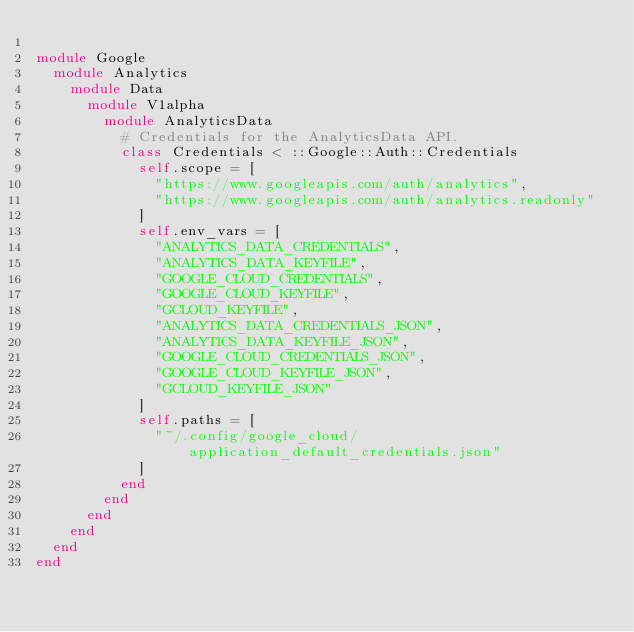Convert code to text. <code><loc_0><loc_0><loc_500><loc_500><_Ruby_>
module Google
  module Analytics
    module Data
      module V1alpha
        module AnalyticsData
          # Credentials for the AnalyticsData API.
          class Credentials < ::Google::Auth::Credentials
            self.scope = [
              "https://www.googleapis.com/auth/analytics",
              "https://www.googleapis.com/auth/analytics.readonly"
            ]
            self.env_vars = [
              "ANALYTICS_DATA_CREDENTIALS",
              "ANALYTICS_DATA_KEYFILE",
              "GOOGLE_CLOUD_CREDENTIALS",
              "GOOGLE_CLOUD_KEYFILE",
              "GCLOUD_KEYFILE",
              "ANALYTICS_DATA_CREDENTIALS_JSON",
              "ANALYTICS_DATA_KEYFILE_JSON",
              "GOOGLE_CLOUD_CREDENTIALS_JSON",
              "GOOGLE_CLOUD_KEYFILE_JSON",
              "GCLOUD_KEYFILE_JSON"
            ]
            self.paths = [
              "~/.config/google_cloud/application_default_credentials.json"
            ]
          end
        end
      end
    end
  end
end
</code> 